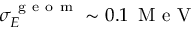Convert formula to latex. <formula><loc_0><loc_0><loc_500><loc_500>\sigma _ { E } ^ { g e o m } \sim 0 . 1 \, M e V</formula> 